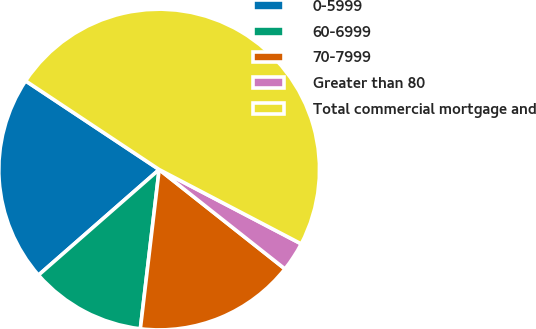Convert chart to OTSL. <chart><loc_0><loc_0><loc_500><loc_500><pie_chart><fcel>0-5999<fcel>60-6999<fcel>70-7999<fcel>Greater than 80<fcel>Total commercial mortgage and<nl><fcel>20.77%<fcel>11.69%<fcel>16.23%<fcel>2.97%<fcel>48.35%<nl></chart> 